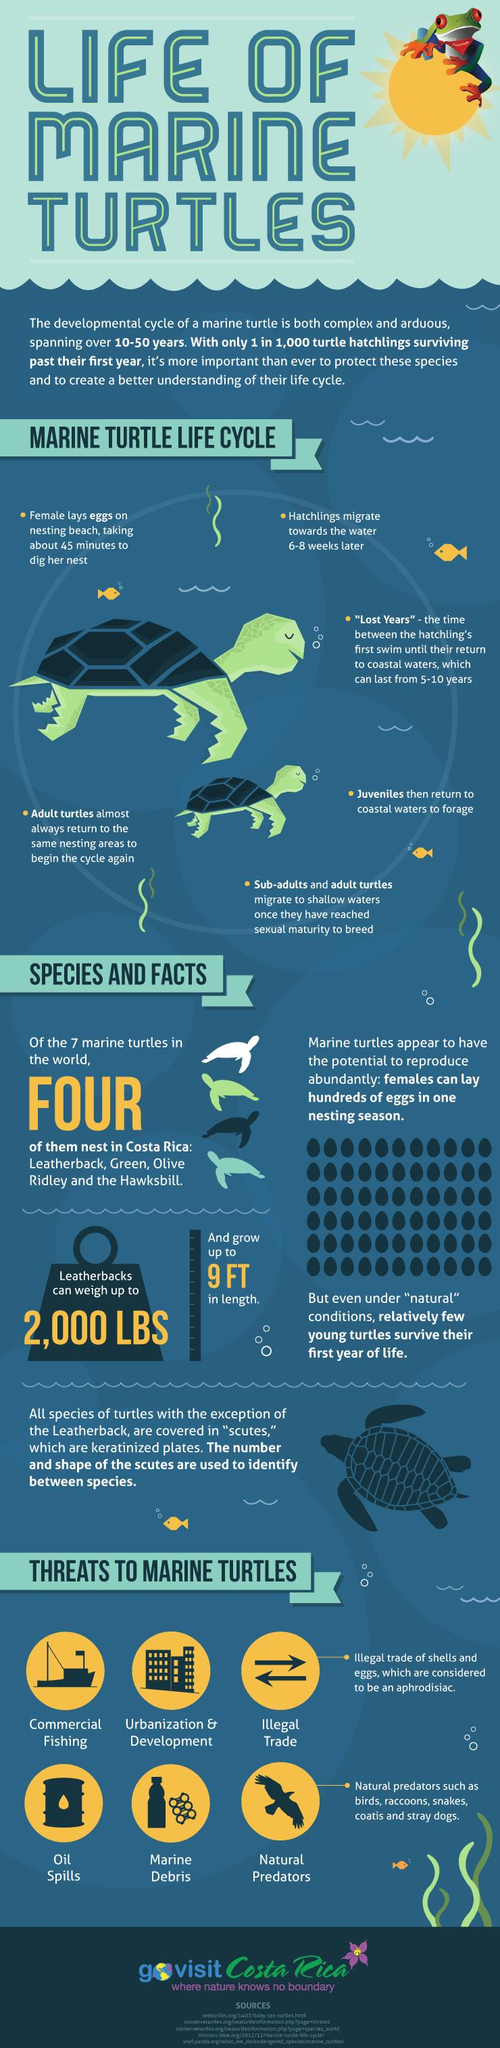Specify some key components in this picture. There are three species of marine turtles that reside in Costa Rica, with the exception of the Hawksbill. These species include the Leatherback, Green, and Olive Ridley turtles. The Leatherback turtle can reach a maximum length of 9 feet, making it one of the largest sea turtles in the world. There are 7 species of marine turtles in the world. Leatherback turtles can weigh up to 2,000 pounds, making them some of the heaviest sea turtles in the world. 